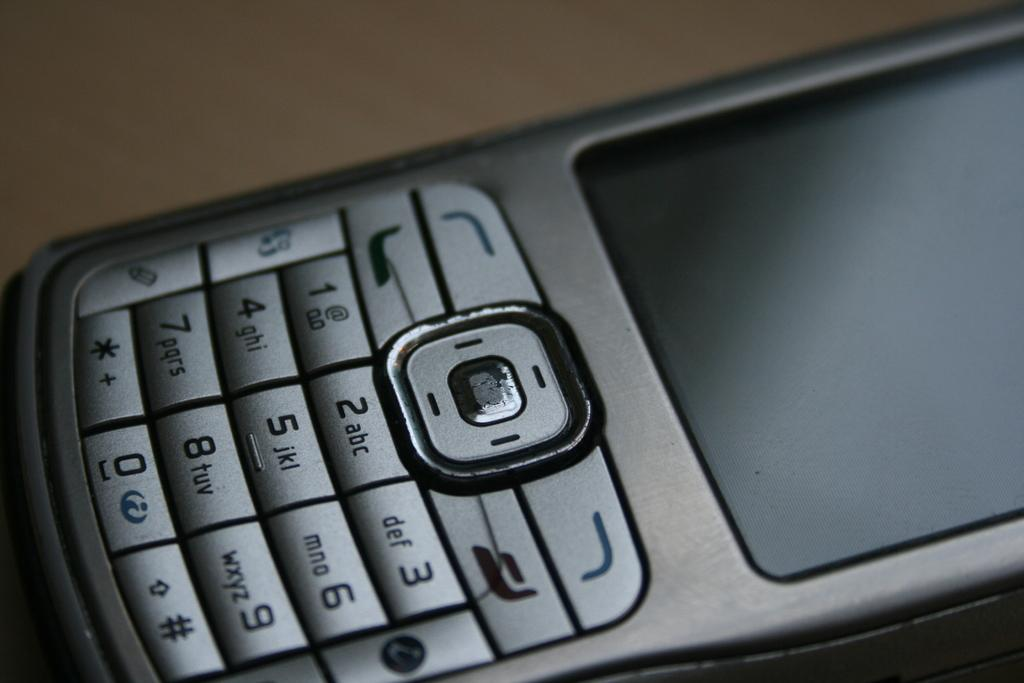<image>
Offer a succinct explanation of the picture presented. a close up of a cell phone keypad with keys 2ABC on it 